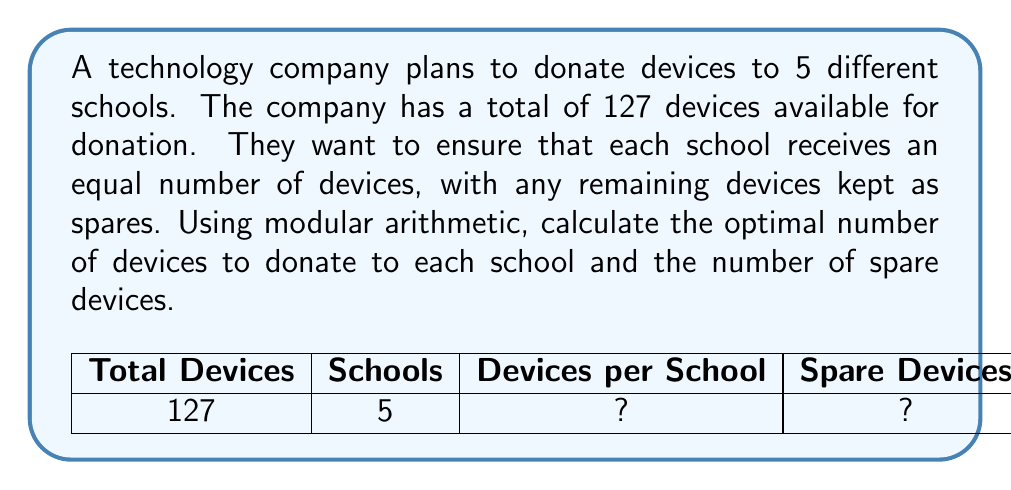Provide a solution to this math problem. Let's approach this step-by-step using modular arithmetic:

1) Let $x$ be the number of devices donated to each school.

2) Since there are 5 schools, the total number of donated devices will be $5x$.

3) We can express this as a congruence relation:
   
   $5x \equiv 127 \pmod{5}$

4) Simplify the right side using the modulo operation:
   
   $5x \equiv 2 \pmod{5}$

5) Multiply both sides by the modular multiplicative inverse of 5 (mod 5), which is 1:
   
   $x \equiv 2 \cdot 1 \equiv 2 \pmod{5}$

6) This means that $x = 5q + 2$ for some integer $q$.

7) The largest value of $x$ that satisfies this and is less than or equal to $\frac{127}{5} = 25.4$ is 22.

8) Therefore, each school should receive 22 devices.

9) The total number of donated devices is $5 \cdot 22 = 110$.

10) The number of spare devices is $127 - 110 = 17$.
Answer: 22 devices per school, 17 spare devices 